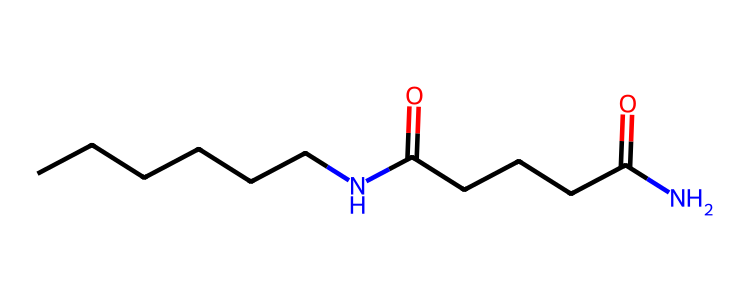What is the main functional group present in this molecule? The molecule contains amide functional groups, indicated by the presence of the -C(=O)N- linkage. This is a characteristic feature of nylon, which consists of repeating units connected by amide bonds.
Answer: amide How many carbon atoms are in the chemical structure? To determine the number of carbon atoms, we can count the carbon symbols (C) in the SMILES representation. There are 10 carbons represented, found in the linear chains.
Answer: 10 What type of plastic is described by this SMILES notation? Given the amide linkages and the linear arrangement of the molecule, this chemical corresponds specifically to nylon, a type of polyamide that is commonly used in outdoor gear.
Answer: nylon What is the total number of nitrogen atoms in the structure? The SMILES notation shows two nitrogen (N) atoms, which are part of the amide functional groups, necessary for the polymerization of nylon.
Answer: 2 What is the significance of the carbon chains in the structure? The long carbon chains contribute to the polymer's mechanical strength and flexibility that are essential characteristics for outdoor gear. The length of the chains affects the overall physical properties of the nylon.
Answer: mechanical strength How many amide bonds are present in the molecule? By analyzing the structure, we see that there are two amide groups evident from the connections (N(C) and C(=O)), indicating the number of amide bonds is two.
Answer: 2 